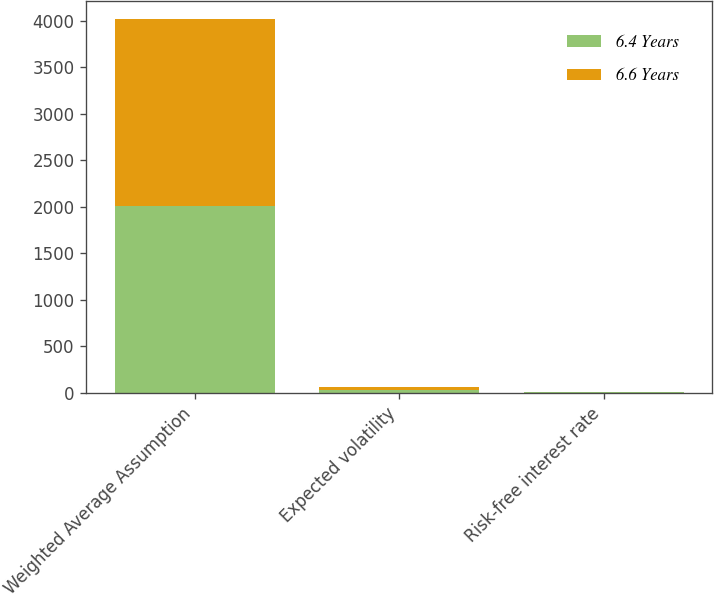<chart> <loc_0><loc_0><loc_500><loc_500><stacked_bar_chart><ecel><fcel>Weighted Average Assumption<fcel>Expected volatility<fcel>Risk-free interest rate<nl><fcel>6.4 Years<fcel>2008<fcel>26.7<fcel>2.98<nl><fcel>6.6 Years<fcel>2009<fcel>32.1<fcel>2.64<nl></chart> 